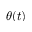<formula> <loc_0><loc_0><loc_500><loc_500>\theta ( t )</formula> 